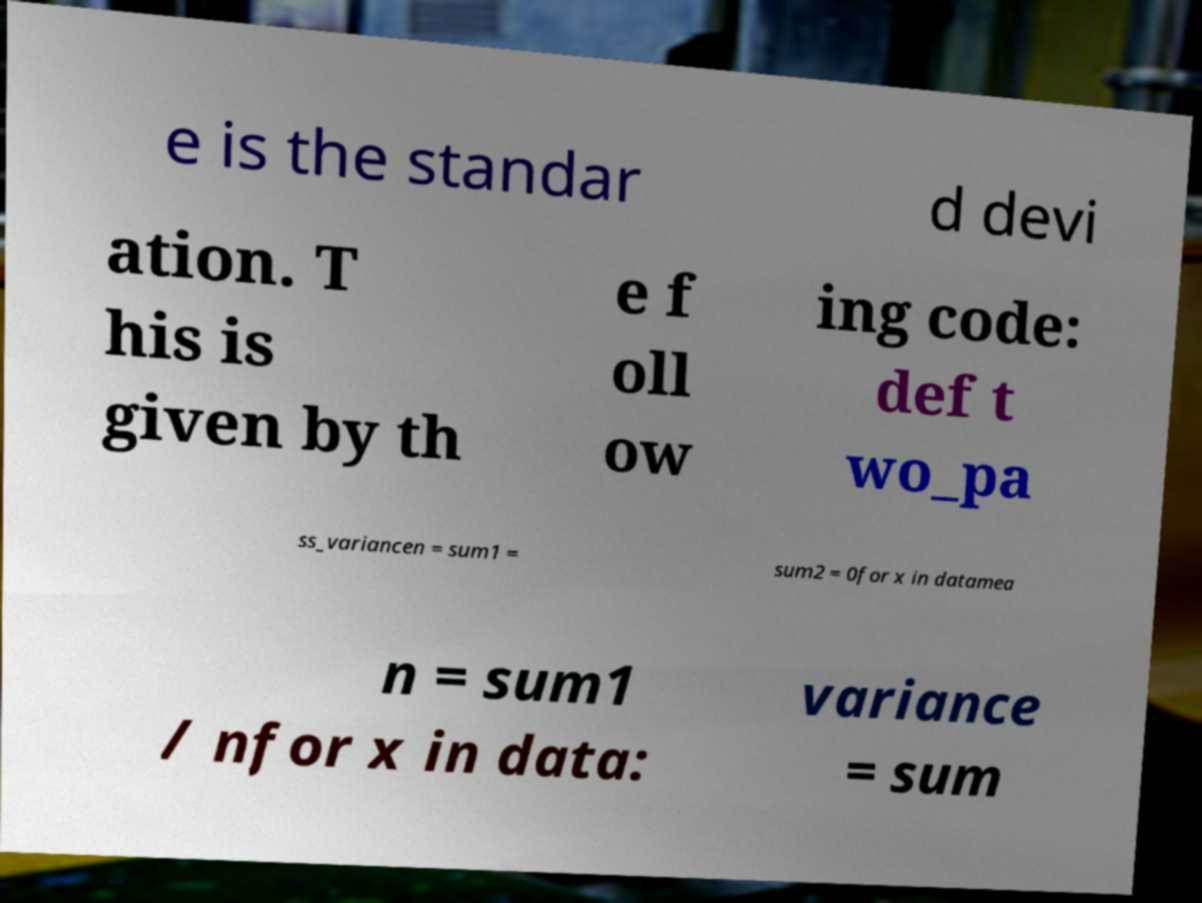There's text embedded in this image that I need extracted. Can you transcribe it verbatim? e is the standar d devi ation. T his is given by th e f oll ow ing code: def t wo_pa ss_variancen = sum1 = sum2 = 0for x in datamea n = sum1 / nfor x in data: variance = sum 